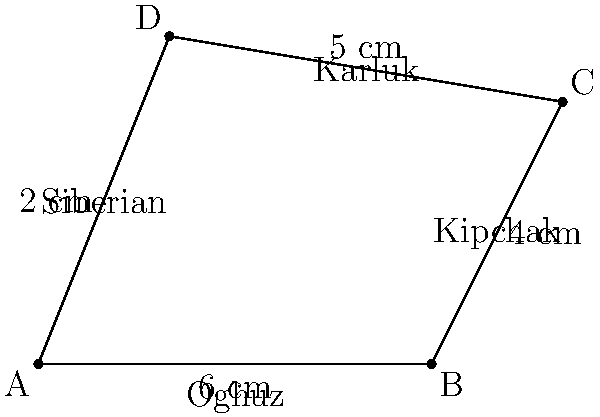In the irregular quadrilateral ABCD representing the four major Turkic language groups (Oghuz, Kipchak, Karluk, and Siberian), the side lengths are given as follows: AB = 6 cm, BC = 4 cm, CD = 5 cm, and DA = 2 cm. If the diagonal AC divides the quadrilateral into two triangles with areas 12 cm² and 18 cm², what is the total area of the quadrilateral in square centimeters? To solve this problem, we'll follow these steps:

1) First, let's recall that the area of a quadrilateral divided by a diagonal is equal to the sum of the areas of the two triangles formed by that diagonal.

2) In this case, we're given that diagonal AC divides the quadrilateral into two triangles with areas 12 cm² and 18 cm².

3) To find the total area of the quadrilateral, we simply need to add these two areas:

   Area of quadrilateral ABCD = Area of triangle ABC + Area of triangle ACD
   $$ A_{ABCD} = 12 \text{ cm}^2 + 18 \text{ cm}^2 $$

4) Calculating the sum:

   $$ A_{ABCD} = 30 \text{ cm}^2 $$

Therefore, the total area of the quadrilateral representing the four major Turkic language groups is 30 square centimeters.
Answer: 30 cm² 